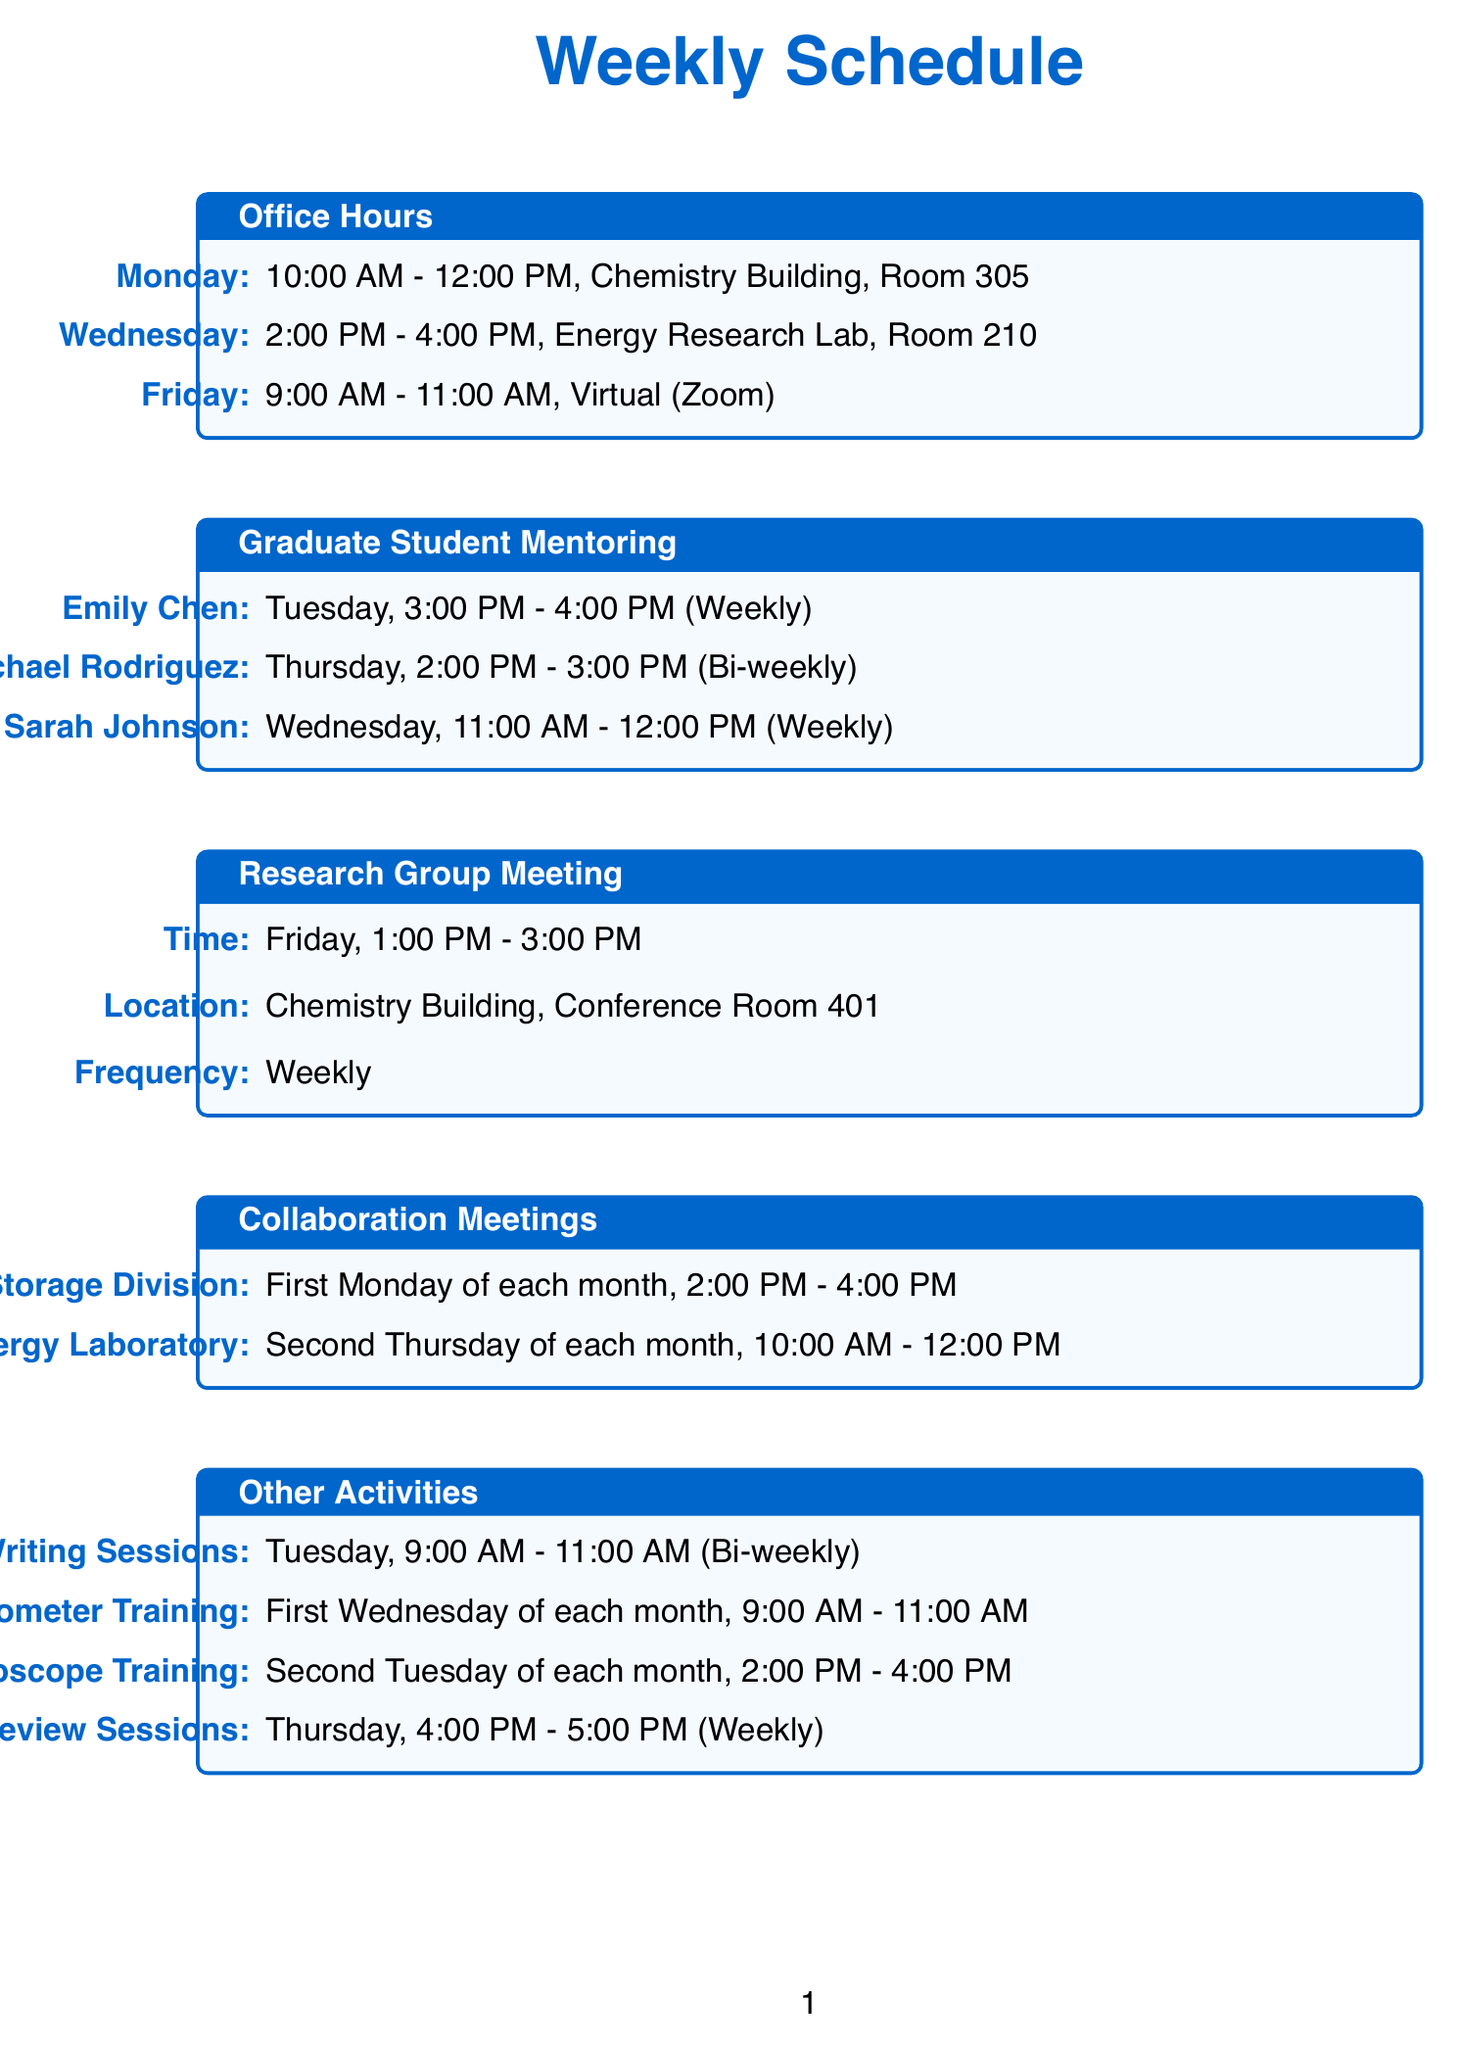What day are office hours held in Room 305? Office hours are scheduled in Room 305 on Monday from 10:00 AM to 12:00 PM.
Answer: Monday What is the location for the graduate student mentoring appointments with Sarah Johnson? Sarah Johnson's mentoring appointment is on Wednesday in Chemistry Building, Room 305.
Answer: Chemistry Building, Room 305 How often does Emily Chen meet for mentoring? Emily Chen has weekly meetings scheduled for her mentoring sessions.
Answer: Weekly What equipment training is scheduled on the first Wednesday of the month? The X-ray Diffractometer training is scheduled on the first Wednesday of each month from 9:00 AM to 11:00 AM.
Answer: X-ray Diffractometer On which day is the next-generation EV battery development meeting with Tesla? The meeting with Tesla Energy Storage Division is on the first Monday of each month.
Answer: First Monday of each month What is the frequency of the research group meetings? The research group meetings occur weekly every Friday.
Answer: Weekly What time is the manuscript review session held each Thursday? The manuscript review session is scheduled from 4:00 PM to 5:00 PM each Thursday.
Answer: 4:00 PM - 5:00 PM When does Michael Rodriguez have his mentoring session? Michael Rodriguez's session is scheduled for Thursday from 2:00 PM to 3:00 PM.
Answer: Thursday, 2:00 PM - 3:00 PM What is the frequency of the grant writing sessions? The grant writing sessions occur bi-weekly on Tuesdays.
Answer: Bi-weekly 